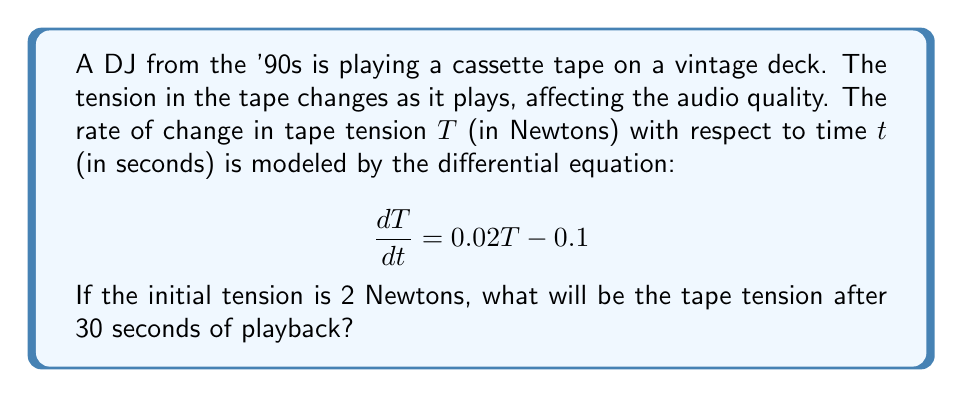Can you solve this math problem? To solve this problem, we need to use the method for solving first-order linear differential equations.

1) The given differential equation is in the form:
   $$\frac{dT}{dt} = aT + b$$
   where $a = 0.02$ and $b = -0.1$

2) The general solution for this type of equation is:
   $$T(t) = ce^{at} - \frac{b}{a}$$
   where $c$ is a constant we need to determine using the initial condition.

3) Substituting the values:
   $$T(t) = ce^{0.02t} + 5$$

4) Using the initial condition $T(0) = 2$:
   $$2 = ce^{0.02(0)} + 5$$
   $$2 = c + 5$$
   $$c = -3$$

5) Therefore, the particular solution is:
   $$T(t) = -3e^{0.02t} + 5$$

6) To find the tension after 30 seconds, we substitute $t = 30$:
   $$T(30) = -3e^{0.02(30)} + 5$$
   $$T(30) = -3e^{0.6} + 5$$
   $$T(30) = -3(1.8221) + 5$$
   $$T(30) = -5.4663 + 5$$
   $$T(30) = -0.4663$$

7) However, since tension cannot be negative in this context, we interpret this result as the tape having lost all tension.
Answer: The tape tension after 30 seconds will be approximately 0 Newtons, indicating that the tape has lost all tension. 